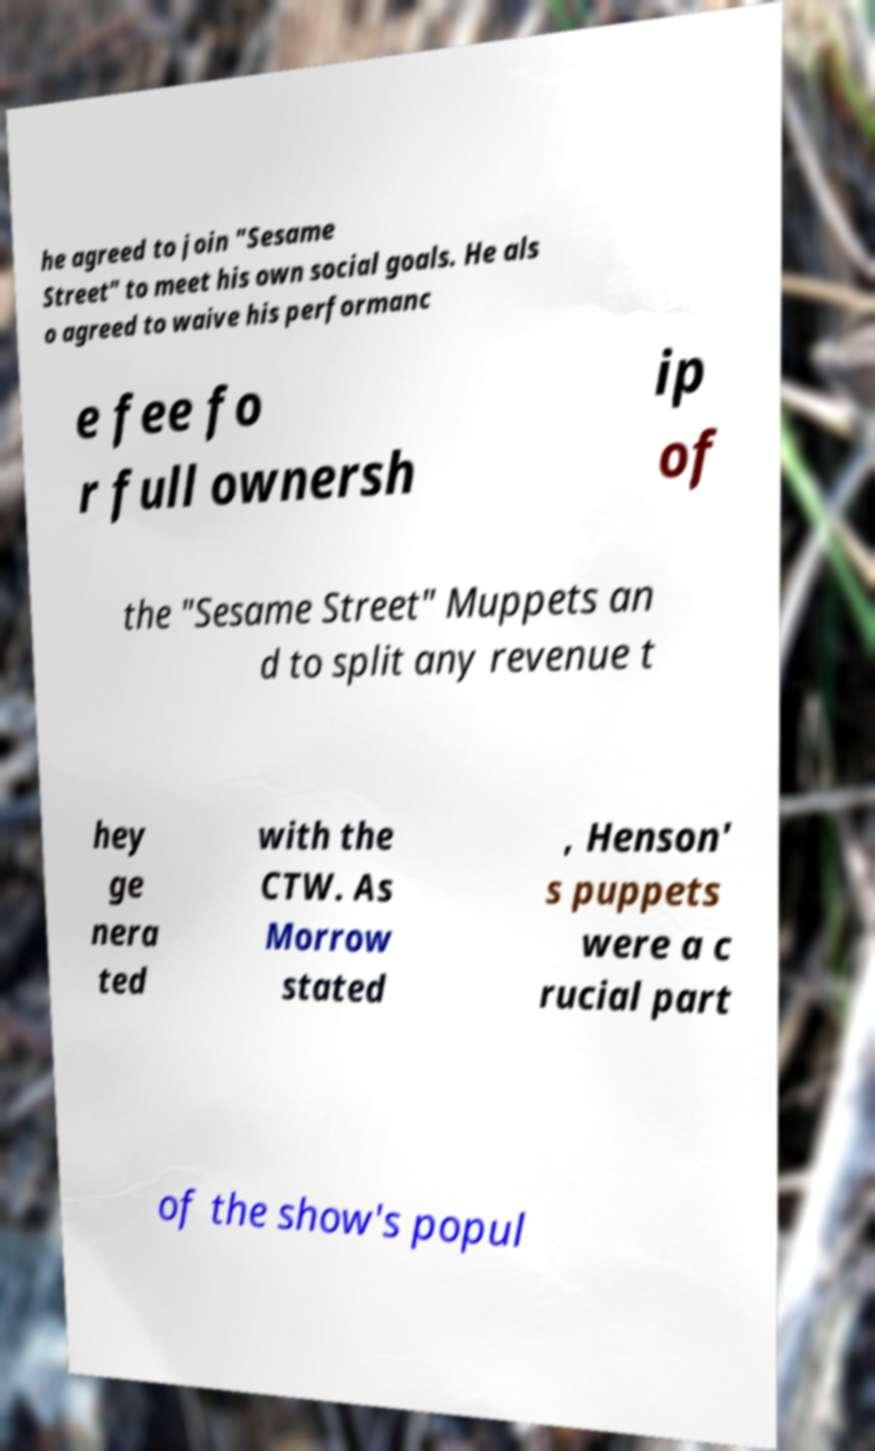Please read and relay the text visible in this image. What does it say? he agreed to join "Sesame Street" to meet his own social goals. He als o agreed to waive his performanc e fee fo r full ownersh ip of the "Sesame Street" Muppets an d to split any revenue t hey ge nera ted with the CTW. As Morrow stated , Henson' s puppets were a c rucial part of the show's popul 